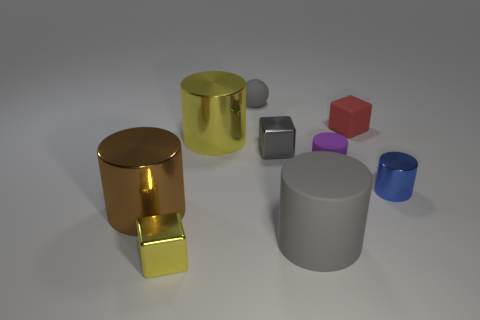Subtract all brown shiny cylinders. How many cylinders are left? 4 Subtract all yellow cylinders. How many cylinders are left? 4 Subtract all green cylinders. Subtract all brown blocks. How many cylinders are left? 5 Add 1 blue cylinders. How many objects exist? 10 Subtract 0 green cylinders. How many objects are left? 9 Subtract all cylinders. How many objects are left? 4 Subtract all shiny cylinders. Subtract all rubber cylinders. How many objects are left? 4 Add 1 large brown metal cylinders. How many large brown metal cylinders are left? 2 Add 5 gray matte cylinders. How many gray matte cylinders exist? 6 